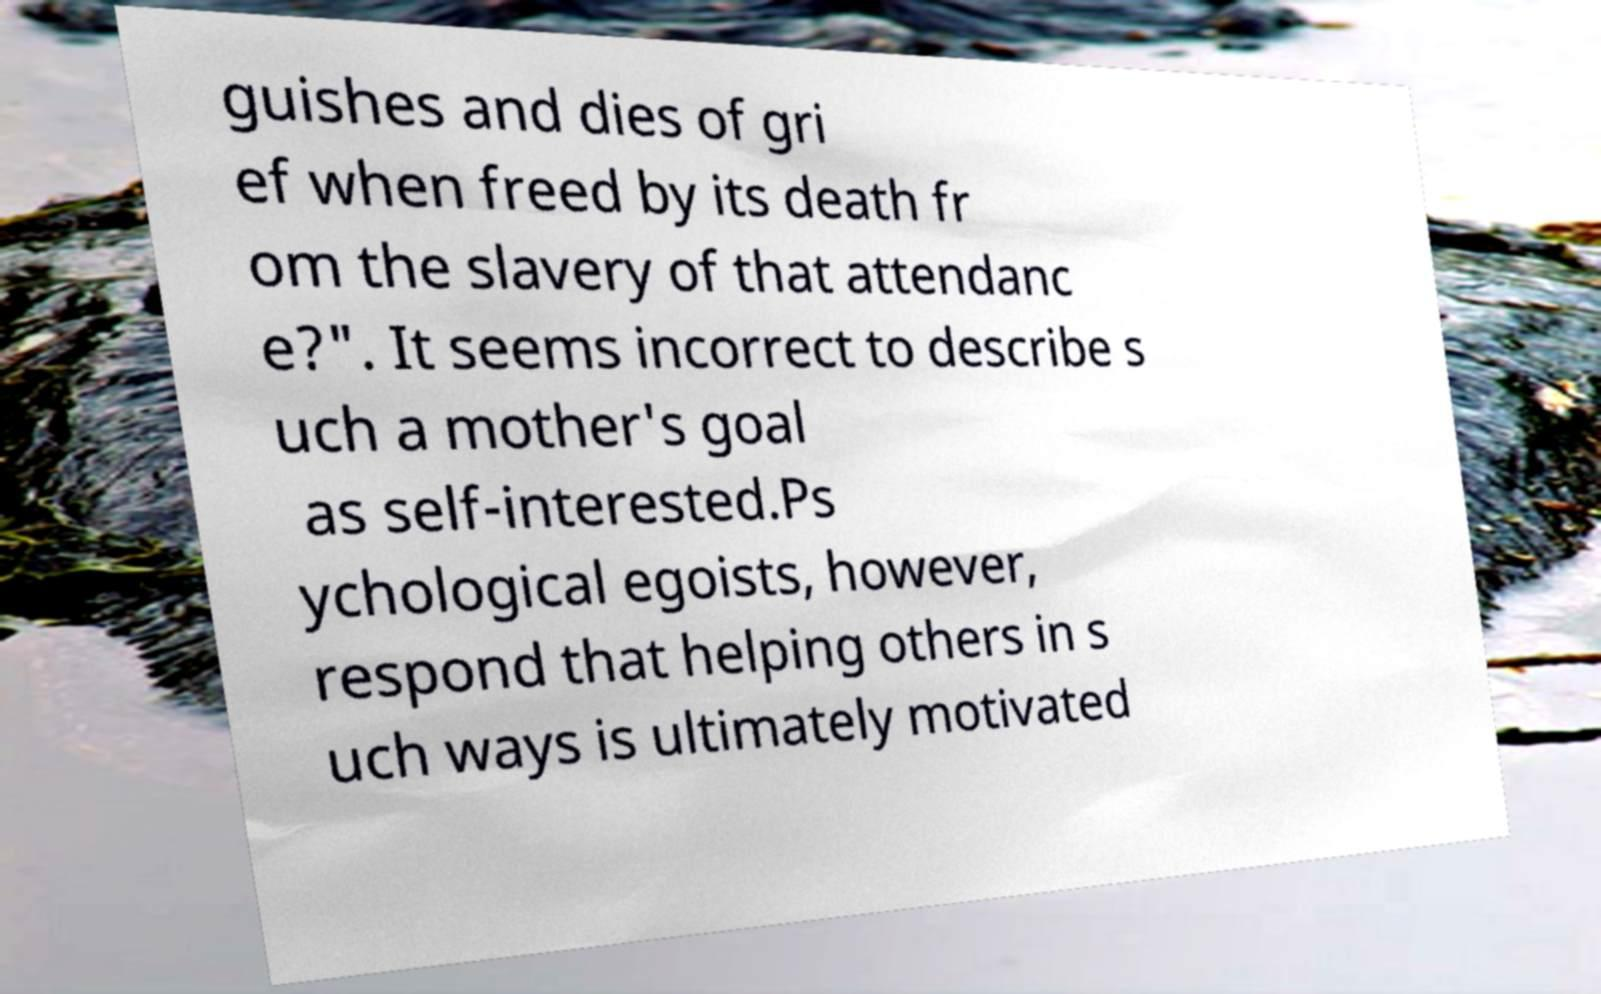I need the written content from this picture converted into text. Can you do that? guishes and dies of gri ef when freed by its death fr om the slavery of that attendanc e?". It seems incorrect to describe s uch a mother's goal as self-interested.Ps ychological egoists, however, respond that helping others in s uch ways is ultimately motivated 